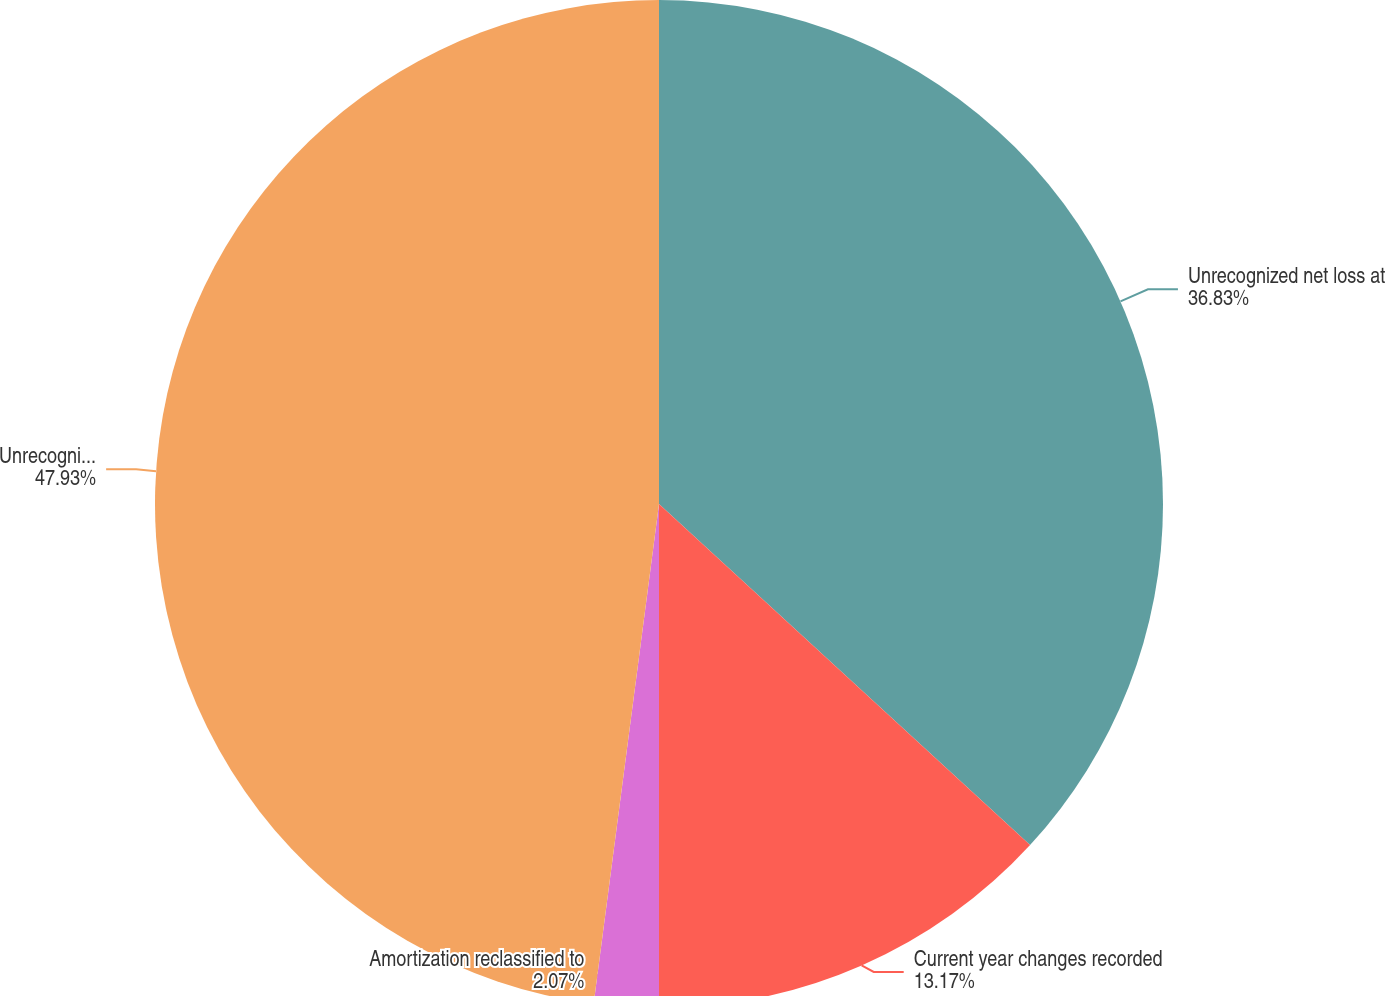<chart> <loc_0><loc_0><loc_500><loc_500><pie_chart><fcel>Unrecognized net loss at<fcel>Current year changes recorded<fcel>Amortization reclassified to<fcel>Unrecognized net loss at end<nl><fcel>36.83%<fcel>13.17%<fcel>2.07%<fcel>47.93%<nl></chart> 